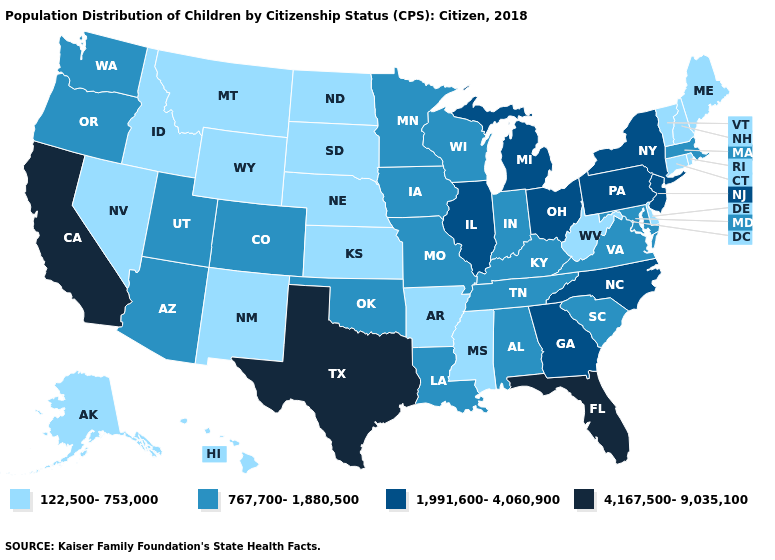Does Texas have the highest value in the USA?
Keep it brief. Yes. Name the states that have a value in the range 1,991,600-4,060,900?
Be succinct. Georgia, Illinois, Michigan, New Jersey, New York, North Carolina, Ohio, Pennsylvania. Among the states that border North Carolina , which have the highest value?
Keep it brief. Georgia. Does Missouri have the highest value in the MidWest?
Short answer required. No. What is the lowest value in the West?
Be succinct. 122,500-753,000. What is the value of South Carolina?
Answer briefly. 767,700-1,880,500. Among the states that border Virginia , which have the highest value?
Write a very short answer. North Carolina. What is the value of Arizona?
Quick response, please. 767,700-1,880,500. Among the states that border Wyoming , which have the lowest value?
Quick response, please. Idaho, Montana, Nebraska, South Dakota. Does Ohio have a higher value than New Mexico?
Give a very brief answer. Yes. Name the states that have a value in the range 1,991,600-4,060,900?
Short answer required. Georgia, Illinois, Michigan, New Jersey, New York, North Carolina, Ohio, Pennsylvania. Which states have the lowest value in the USA?
Write a very short answer. Alaska, Arkansas, Connecticut, Delaware, Hawaii, Idaho, Kansas, Maine, Mississippi, Montana, Nebraska, Nevada, New Hampshire, New Mexico, North Dakota, Rhode Island, South Dakota, Vermont, West Virginia, Wyoming. What is the value of North Dakota?
Give a very brief answer. 122,500-753,000. Name the states that have a value in the range 122,500-753,000?
Quick response, please. Alaska, Arkansas, Connecticut, Delaware, Hawaii, Idaho, Kansas, Maine, Mississippi, Montana, Nebraska, Nevada, New Hampshire, New Mexico, North Dakota, Rhode Island, South Dakota, Vermont, West Virginia, Wyoming. 